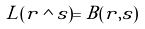<formula> <loc_0><loc_0><loc_500><loc_500>L ( r \wedge s ) = B ( r , s )</formula> 